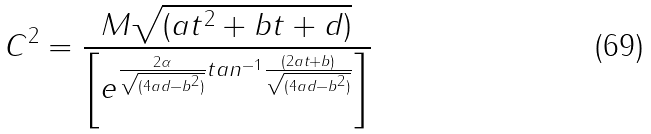<formula> <loc_0><loc_0><loc_500><loc_500>C ^ { 2 } = \frac { M \sqrt { ( a t ^ { 2 } + b t + d ) } } { \left [ e ^ { \frac { 2 \alpha } { \sqrt { ( 4 a d - b ^ { 2 } ) } } t a n ^ { - 1 } \frac { ( 2 a t + b ) } { \sqrt { ( 4 a d - b ^ { 2 } ) } } } \right ] }</formula> 